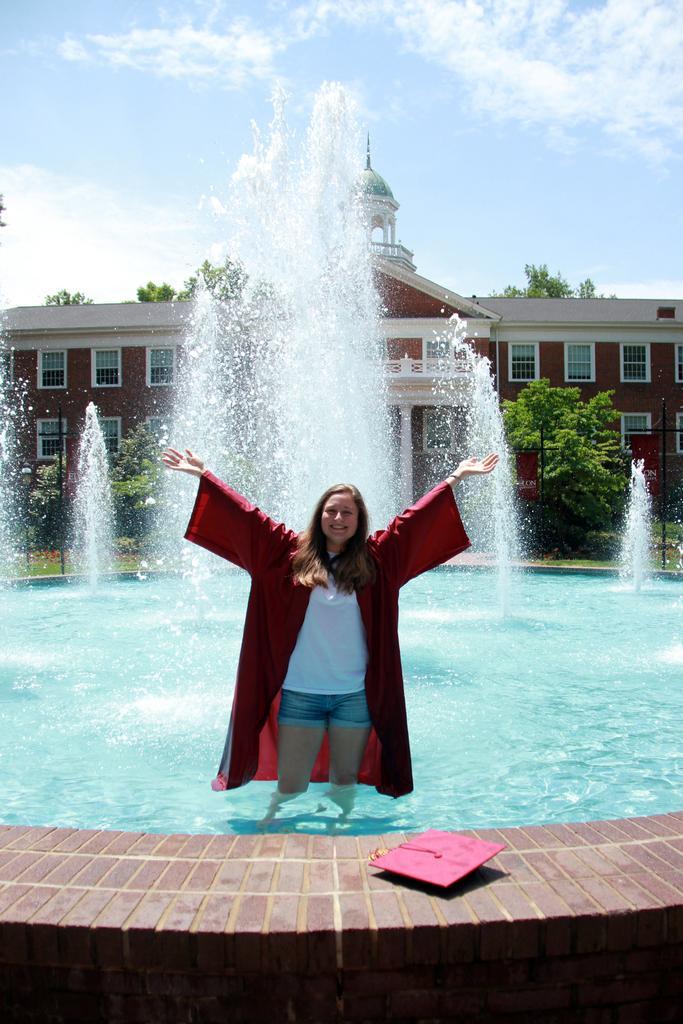In one or two sentences, can you explain what this image depicts? In the center of the image there is a person standing inside the fountain. In front of her there is a hat on the platform. In the background of the image there is a building. There are trees. There is a metal fence and sky. 